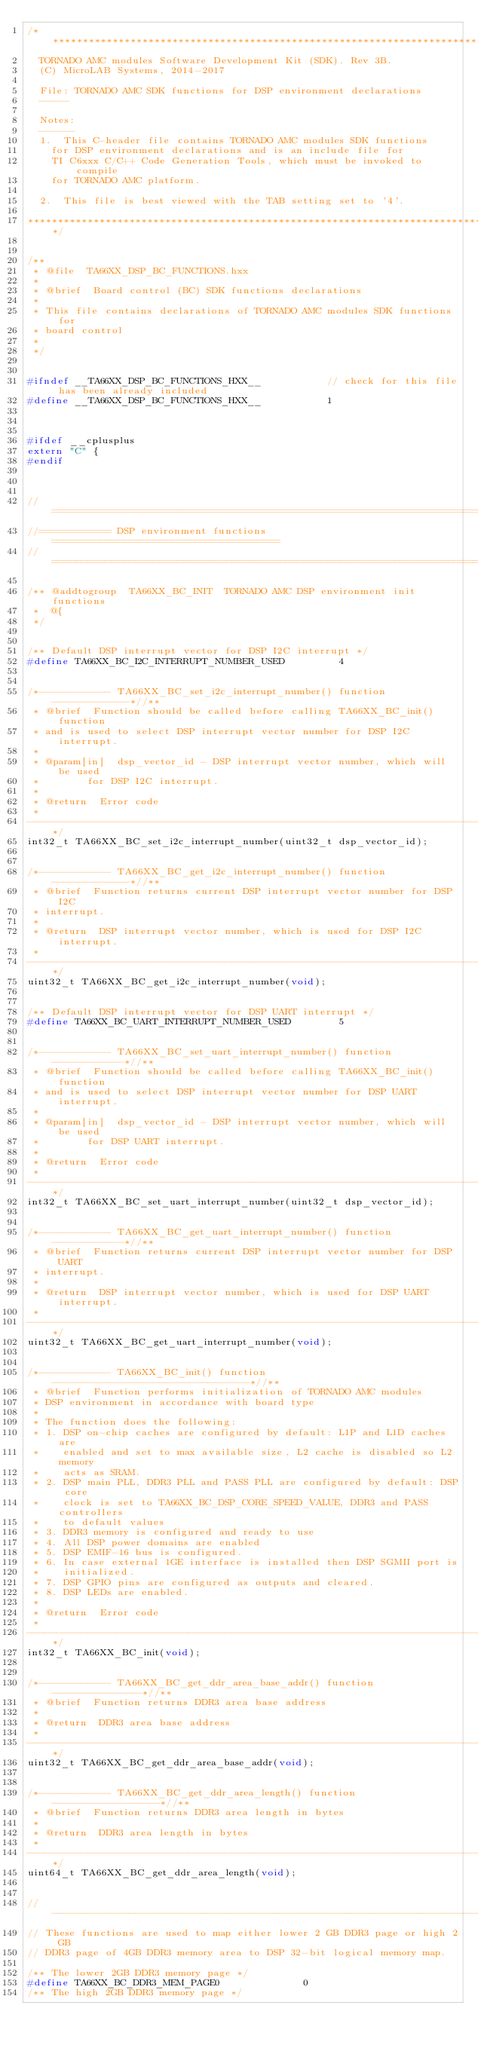<code> <loc_0><loc_0><loc_500><loc_500><_C++_>/******************************************************************************
	TORNADO AMC modules Software Development Kit (SDK). Rev 3B.
	(C) MicroLAB Systems, 2014-2017

	File:	TORNADO AMC SDK functions for DSP environment declarations
	-----

	Notes:
	------
	1.	This C-header file contains TORNADO AMC modules SDK functions 
		for DSP environment declarations and is an include file for
		TI C6xxx C/C++ Code Generation Tools, which must be invoked to compile
		for TORNADO AMC platform.

	2.	This file is best viewed with the TAB setting set to '4'.

******************************************************************************/


/**
 * @file  TA66XX_DSP_BC_FUNCTIONS.hxx
 *
 * @brief  Board control (BC) SDK functions declarations
 *
 * This file contains declarations of TORNADO AMC modules SDK functions for
 * board control
 *
 */


#ifndef __TA66XX_DSP_BC_FUNCTIONS_HXX__						// check for this file has been already included
#define __TA66XX_DSP_BC_FUNCTIONS_HXX__						1



#ifdef __cplusplus
extern "C" {
#endif



//=============================================================================
//============ DSP environment functions ======================================
//=============================================================================

/** @addtogroup  TA66XX_BC_INIT  TORNADO AMC DSP environment init functions
 *  @{
 */


/** Default DSP interrupt vector for DSP I2C interrupt */
#define TA66XX_BC_I2C_INTERRUPT_NUMBER_USED					4


/*------------ TA66XX_BC_set_i2c_interrupt_number() function -------------*//**
 * @brief  Function should be called before calling TA66XX_BC_init() function
 * and is used to select DSP interrupt vector number for DSP I2C interrupt.
 *
 * @param[in]  dsp_vector_id - DSP interrupt vector number, which will be used
 *				for DSP I2C interrupt.
 *
 * @return  Error code
 *
-----------------------------------------------------------------------------*/
int32_t TA66XX_BC_set_i2c_interrupt_number(uint32_t dsp_vector_id);


/*------------ TA66XX_BC_get_i2c_interrupt_number() function -------------*//**
 * @brief  Function returns current DSP interrupt vector number for DSP I2C
 * interrupt.
 *
 * @return  DSP interrupt vector number, which is used for DSP I2C interrupt.
 *
-----------------------------------------------------------------------------*/
uint32_t TA66XX_BC_get_i2c_interrupt_number(void);


/** Default DSP interrupt vector for DSP UART interrupt */
#define TA66XX_BC_UART_INTERRUPT_NUMBER_USED				5


/*------------ TA66XX_BC_set_uart_interrupt_number() function ------------*//**
 * @brief  Function should be called before calling TA66XX_BC_init() function
 * and is used to select DSP interrupt vector number for DSP UART interrupt.
 *
 * @param[in]  dsp_vector_id - DSP interrupt vector number, which will be used
 *				for DSP UART interrupt.
 *
 * @return  Error code
 *
-----------------------------------------------------------------------------*/
int32_t TA66XX_BC_set_uart_interrupt_number(uint32_t dsp_vector_id);


/*------------ TA66XX_BC_get_uart_interrupt_number() function ------------*//**
 * @brief  Function returns current DSP interrupt vector number for DSP UART
 * interrupt.
 *
 * @return  DSP interrupt vector number, which is used for DSP UART interrupt.
 *
-----------------------------------------------------------------------------*/
uint32_t TA66XX_BC_get_uart_interrupt_number(void);


/*------------ TA66XX_BC_init() function ---------------------------------*//**
 * @brief  Function performs initialization of TORNADO AMC modules
 * DSP environment in accordance with board type
 *
 * The function does the following:
 * 1. DSP on-chip caches are configured by default: L1P and L1D caches are
 *    enabled and set to max available size, L2 cache is disabled so L2 memory
 *    acts as SRAM.
 * 2. DSP main PLL, DDR3 PLL and PASS PLL are configured by default: DSP core
 *    clock is set to TA66XX_BC_DSP_CORE_SPEED_VALUE, DDR3 and PASS controllers
 *    to default values
 * 3. DDR3 memory is configured and ready to use
 * 4. All DSP power domains are enabled
 * 5. DSP EMIF-16 bus is configured.
 * 6. In case external 1GE interface is installed then DSP SGMII port is
 *    initialized.
 * 7. DSP GPIO pins are configured as outputs and cleared.
 * 8. DSP LEDs are enabled.
 *
 * @return  Error code
 *
-----------------------------------------------------------------------------*/
int32_t TA66XX_BC_init(void);


/*------------ TA66XX_BC_get_ddr_area_base_addr() function ---------------*//**
 * @brief  Function returns DDR3 area base address
 *
 * @return  DDR3 area base address
 *
-----------------------------------------------------------------------------*/
uint32_t TA66XX_BC_get_ddr_area_base_addr(void);


/*------------ TA66XX_BC_get_ddr_area_length() function ------------------*//**
 * @brief  Function returns DDR3 area length in bytes
 *
 * @return  DDR3 area length in bytes
 *
-----------------------------------------------------------------------------*/
uint64_t TA66XX_BC_get_ddr_area_length(void);


//-----------------------------------------------------------------------------
// These functions are used to map either lower 2 GB DDR3 page or high 2 GB
// DDR3 page of 4GB DDR3 memory area to DSP 32-bit logical memory map.

/** The lower 2GB DDR3 memory page */
#define TA66XX_BC_DDR3_MEM_PAGE0							0
/** The high 2GB DDR3 memory page */</code> 